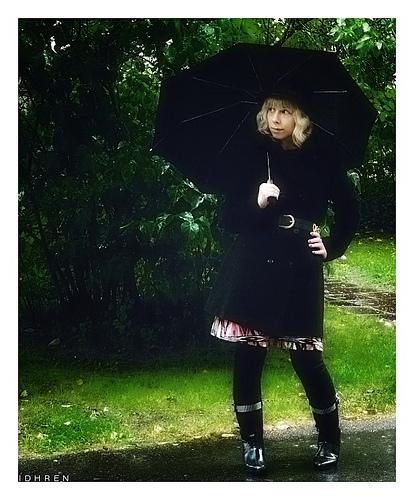Is this a very dry place to be?
Give a very brief answer. No. What color is the woman's umbrella?
Quick response, please. Black. What are the weather conditions?
Short answer required. Rainy. 